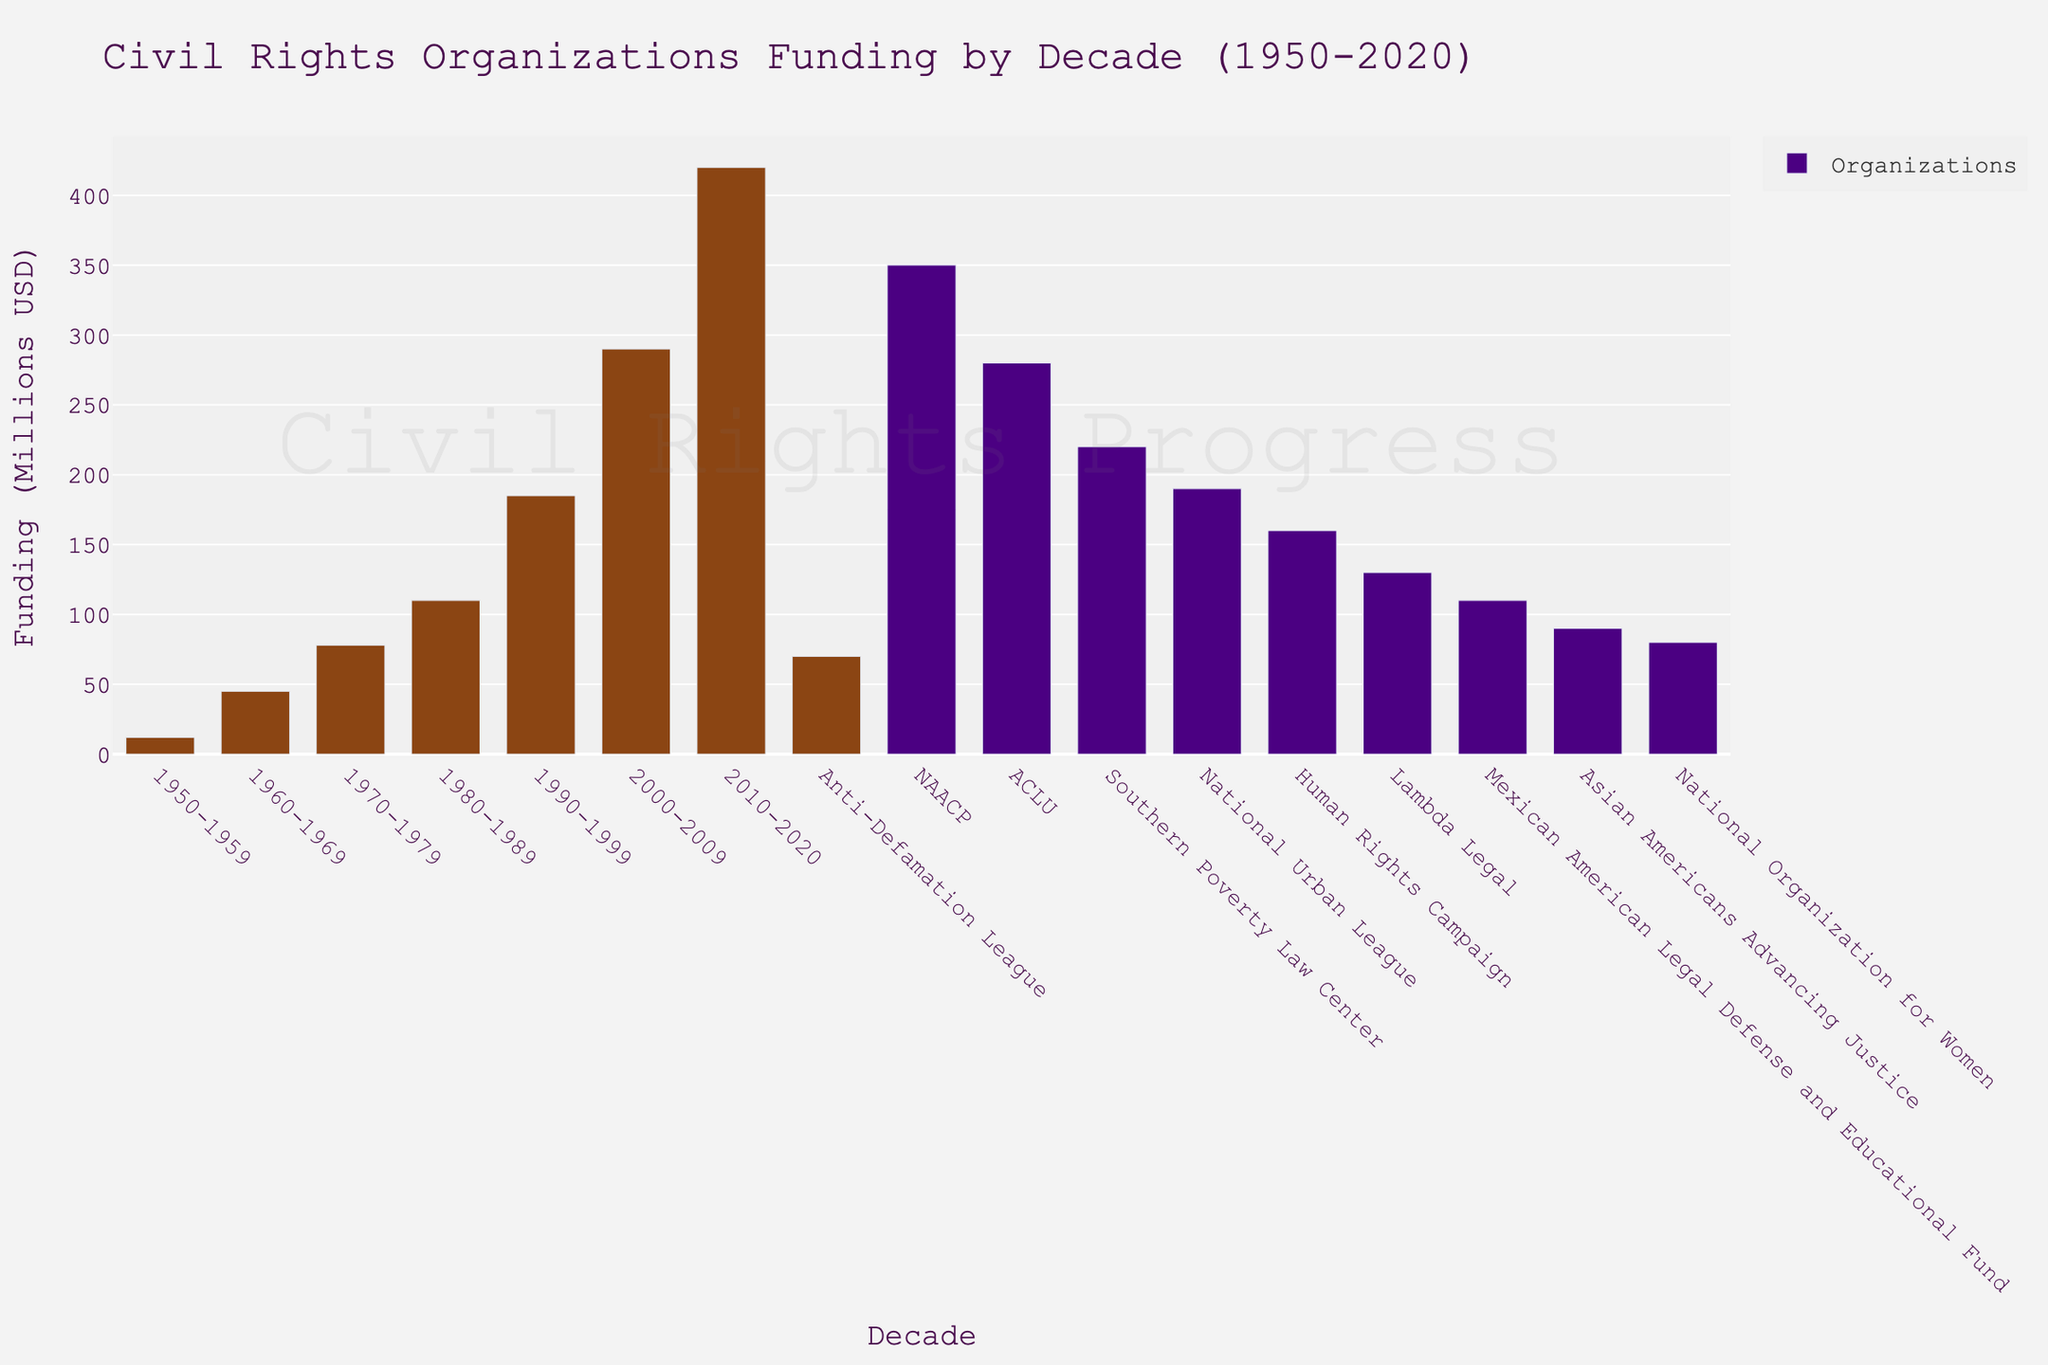what's the total funding allocated to civil rights organizations in the 1950s and 1960s? In the 1950s, funding was 12 million USD and in the 1960s it was 45 million USD. Adding these together (12 + 45) gives a total of 57 million USD.
Answer: 57 million USD Which organization received the most funding? Looking at the bars representing organizations, the NAACP has the tallest bar, indicating it received the most funding.
Answer: NAACP How does the funding in the 2010-2020 decade compare to the 1950-1959 decade? The funding in the 1950-1959 decade is represented by a shorter bar (12 million USD), while the 2010-2020 decade has a much taller bar (420 million USD). Funding in 2010-2020 is higher.
Answer: 2010-2020 Which decade saw the biggest increase in funding compared to the previous decade? By comparing the height of consecutive decade bars, the largest increase appears to be from 2000-2009 (290 million USD) to 2010-2020 (420 million USD), an increase of 130 million USD.
Answer: 2000-2009 to 2010-2020 What is the average funding for the listed organizations? Sum the funding for all organizations (350 + 280 + 220 + 190 + 160 + 130 + 110 + 90 + 80 + 70 = 1680 million USD) and divide by the number of organizations (10). The average is 1680 / 10 = 168 million USD.
Answer: 168 million USD Which organization received less funding than the National Urban League but more than the Lambda Legal? The National Urban League received 190 million USD and the Lambda Legal received 130 million USD. The Anti-Defamation League received 70 million USD, not meeting the criteria. Mexican American Legal Defense and Educational Fund received 110 million USD. Human Rights Campaign received 160 million USD, which fits.
Answer: Human Rights Campaign What's the total funding received by organizations with an "L" in their name? Adding the funding for Lambda Legal (130), National Urban League (190), and Southern Poverty Law Center (220): 130 + 190 + 220 = 540 million USD.
Answer: 540 million USD Is the funding trend from 1950 to 2020 generally increasing, decreasing, or fluctuating? Upon observing the height of the bars from 1950-2020, the funding increases consistently with each decade.
Answer: Increasing Which decade had the least amount of funding? The shortest bar for decades is for 1950-1959, indicating the least amount of funding at 12 million USD.
Answer: 1950-1959 